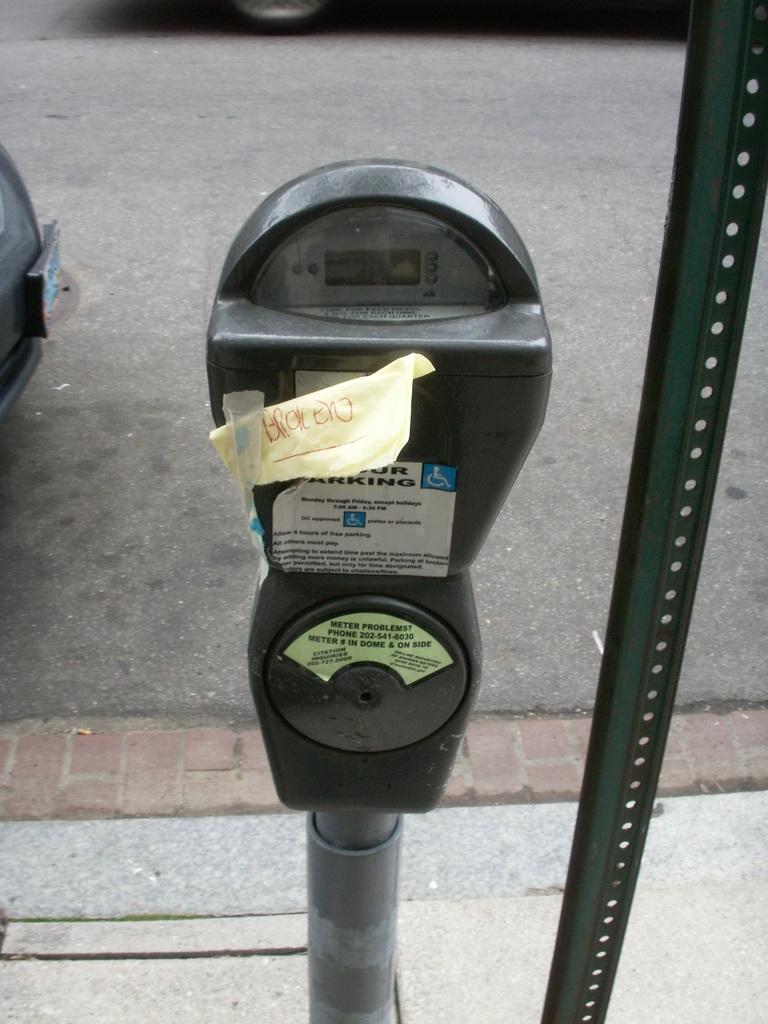Why is the parking meter out of order?
Offer a terse response. Broken. What number do you call for meter problems?
Make the answer very short. 202-541-6030. 